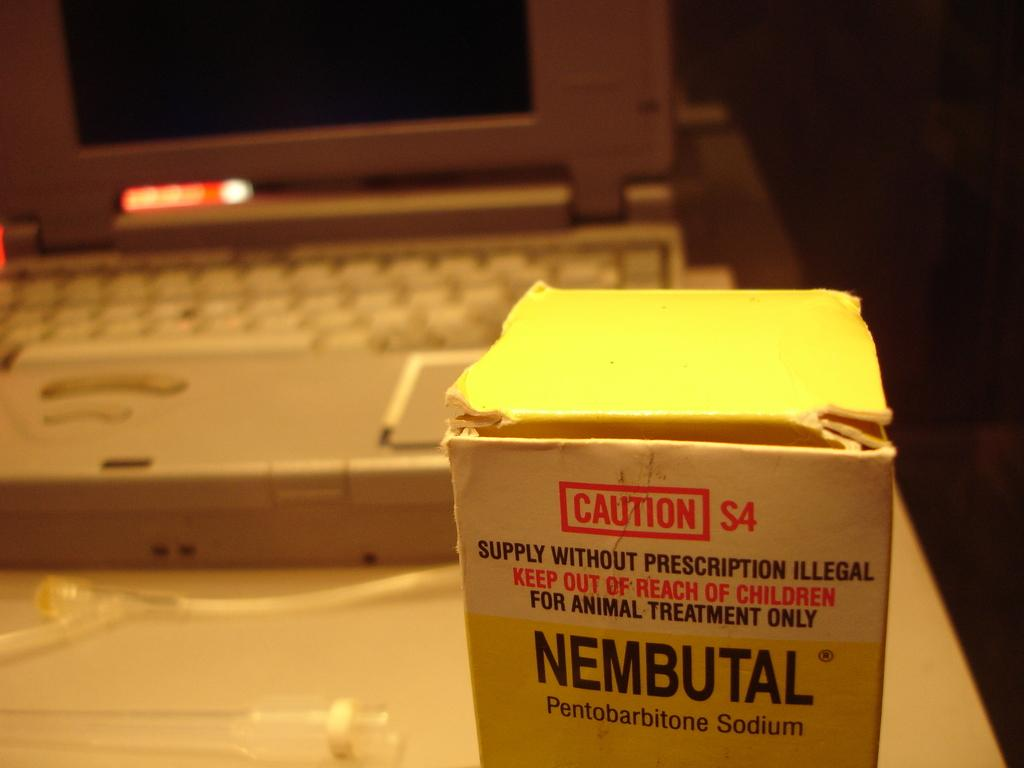<image>
Summarize the visual content of the image. a lap top with a box of Nembutal in front of it 